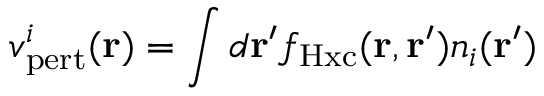Convert formula to latex. <formula><loc_0><loc_0><loc_500><loc_500>v _ { p e r t } ^ { i } ( r ) = \int d r ^ { \prime } f _ { H x c } ( r , r ^ { \prime } ) n _ { i } ( r ^ { \prime } )</formula> 